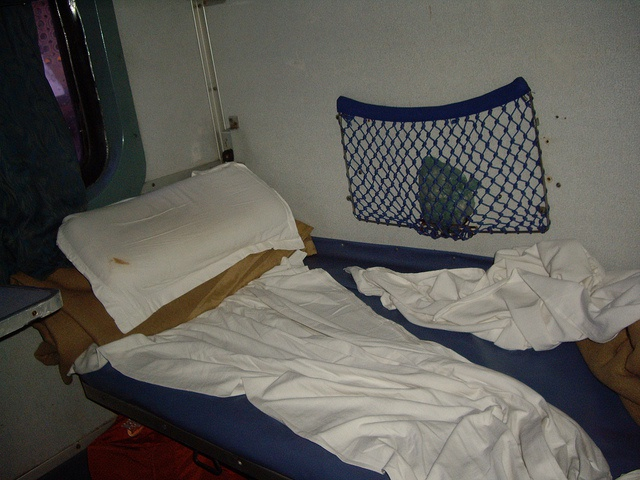Describe the objects in this image and their specific colors. I can see a bed in black, darkgray, and gray tones in this image. 